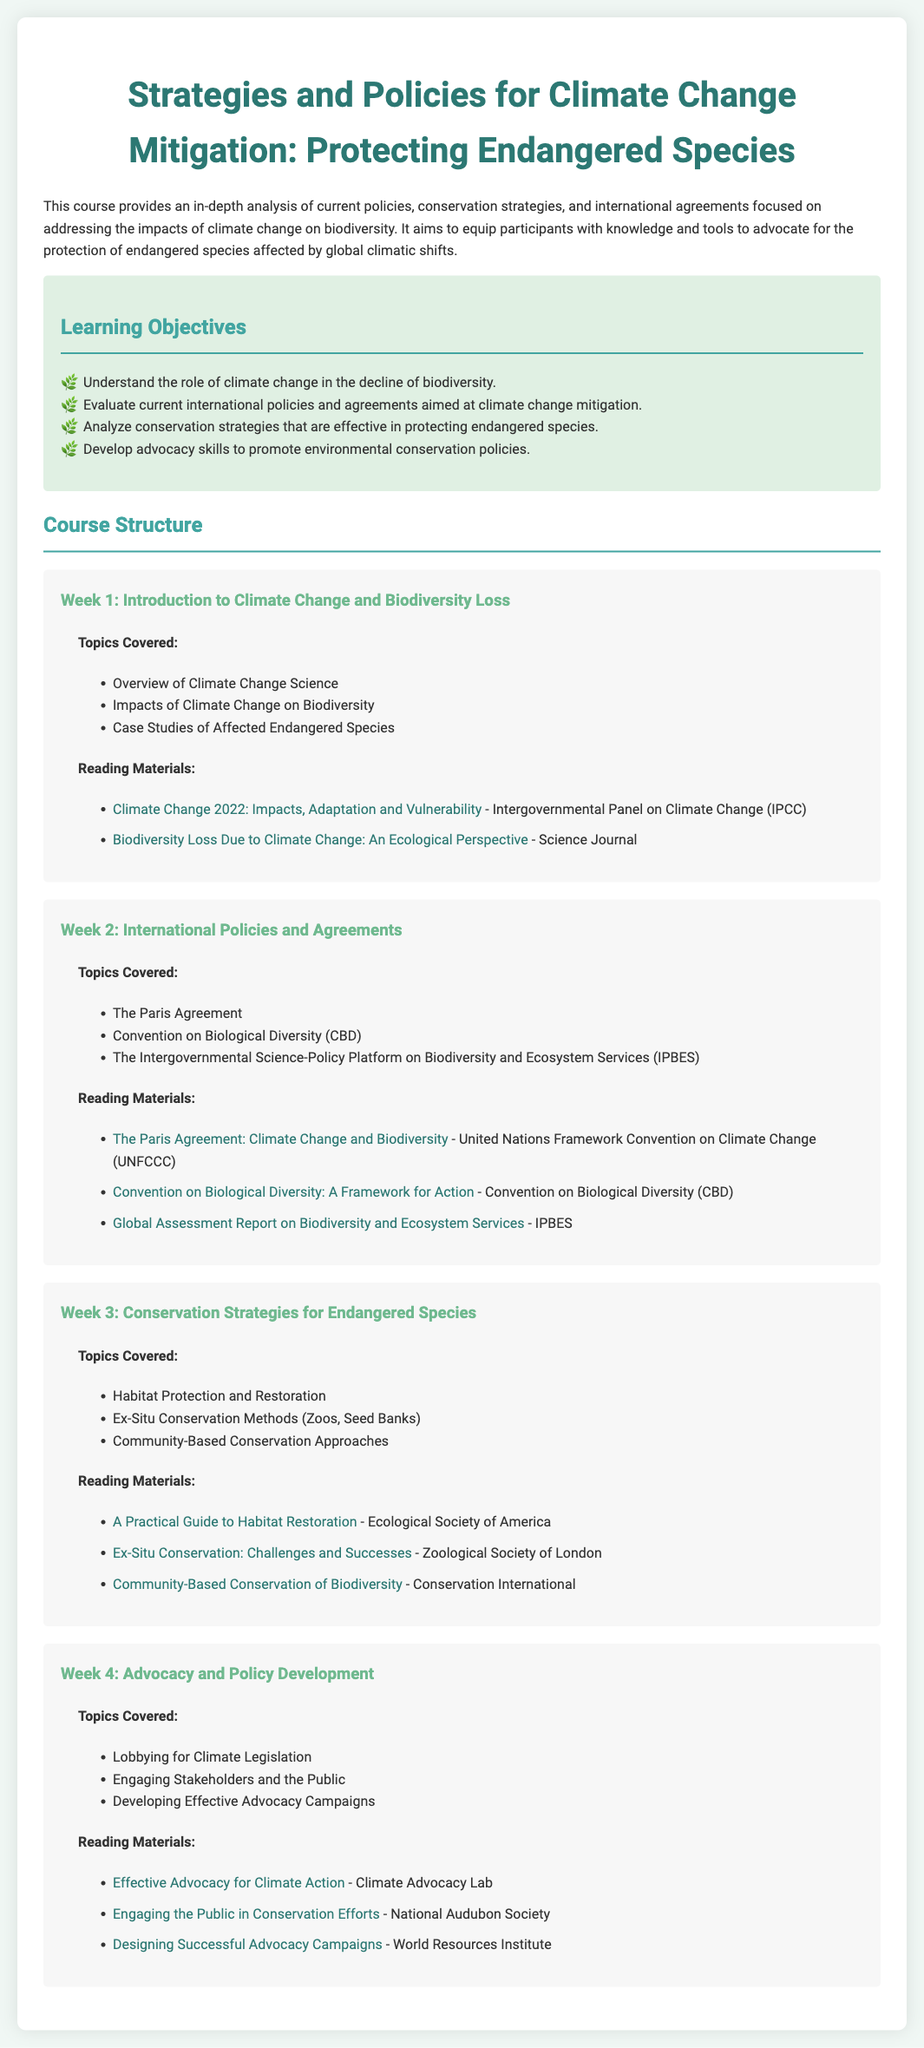What is the main focus of the course? The course provides an in-depth analysis of current policies, conservation strategies, and international agreements focused on addressing the impacts of climate change on biodiversity.
Answer: Climate Change Mitigation What is one of the learning objectives of this course? The document lists several learning objectives, one of which is to evaluate current international policies and agreements aimed at climate change mitigation.
Answer: Evaluate current international policies Who developed the Paris Agreement? The course refers to the Paris Agreement as part of the international policies and agreements on climate change.
Answer: United Nations Framework Convention on Climate Change In which week is habitat protection and restoration discussed? The syllabus specifies that habitat protection and restoration is covered in Week 3.
Answer: Week 3 What type of conservation strategy is mentioned alongside zoos and seed banks? The document lists ex-situ conservation methods, which include zoos and seed banks, as part of conservation strategies.
Answer: Ex-Situ Conservation Methods Which organization is linked to community-based conservation approaches? The syllabus suggests that community-based conservation approaches are associated with Conservation International.
Answer: Conservation International What is the title of the reading material for Week 4 on advocacy? The reading material listed for Week 4 is focused on engaging stakeholders and the public for effective advocacy campaigns.
Answer: Engaging the Public in Conservation Efforts What is a recommended reading for understanding biodiversity loss due to climate change? The document includes multiple readings, including one from "Science Journal" discussing biodiversity loss.
Answer: Biodiversity Loss Due to Climate Change: An Ecological Perspective What is the total number of weeks in the course structure? The course structure includes four weeks of topics and readings.
Answer: Four weeks 